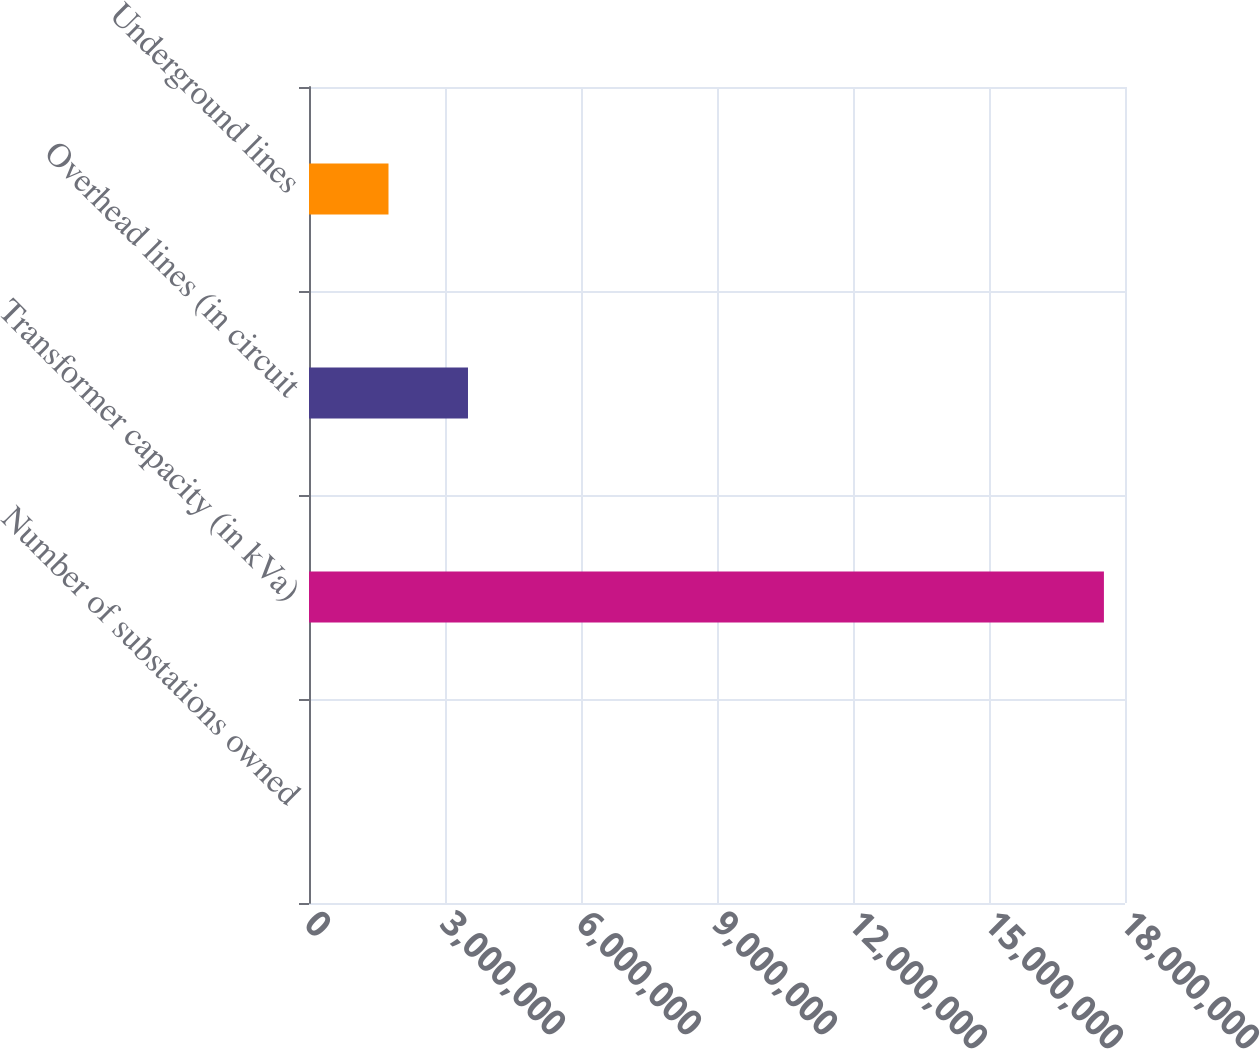Convert chart to OTSL. <chart><loc_0><loc_0><loc_500><loc_500><bar_chart><fcel>Number of substations owned<fcel>Transformer capacity (in kVa)<fcel>Overhead lines (in circuit<fcel>Underground lines<nl><fcel>178<fcel>1.7535e+07<fcel>3.50714e+06<fcel>1.75366e+06<nl></chart> 